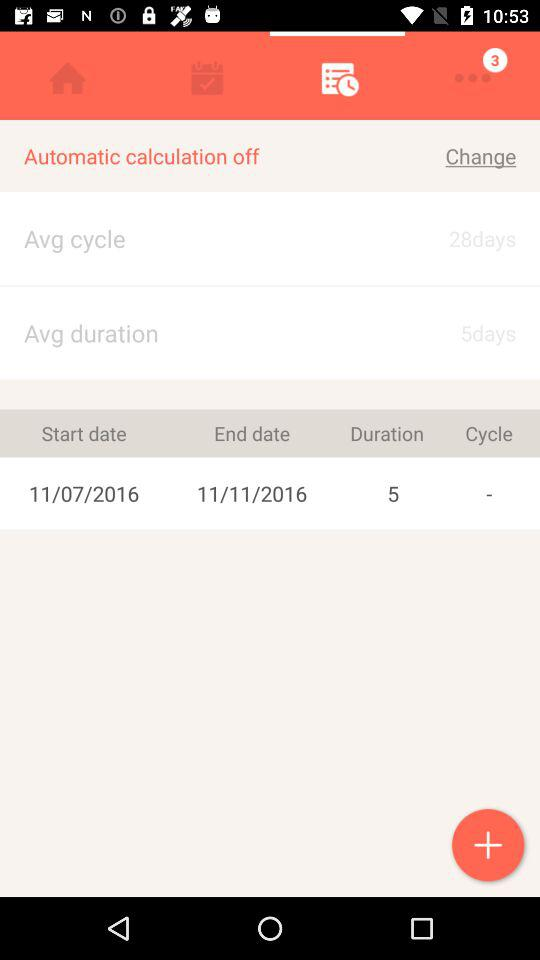How many unread message are displaying?
When the provided information is insufficient, respond with <no answer>. <no answer> 